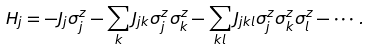<formula> <loc_0><loc_0><loc_500><loc_500>H _ { j } = - J _ { j } \sigma _ { j } ^ { z } - \sum _ { k } J _ { j k } \sigma _ { j } ^ { z } \sigma _ { k } ^ { z } - \sum _ { k l } J _ { j k l } \sigma _ { j } ^ { z } \sigma _ { k } ^ { z } \sigma _ { l } ^ { z } - \cdots .</formula> 